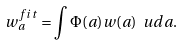<formula> <loc_0><loc_0><loc_500><loc_500>w _ { a } ^ { f i t } = \int \Phi ( a ) w ( a ) \ u d a .</formula> 